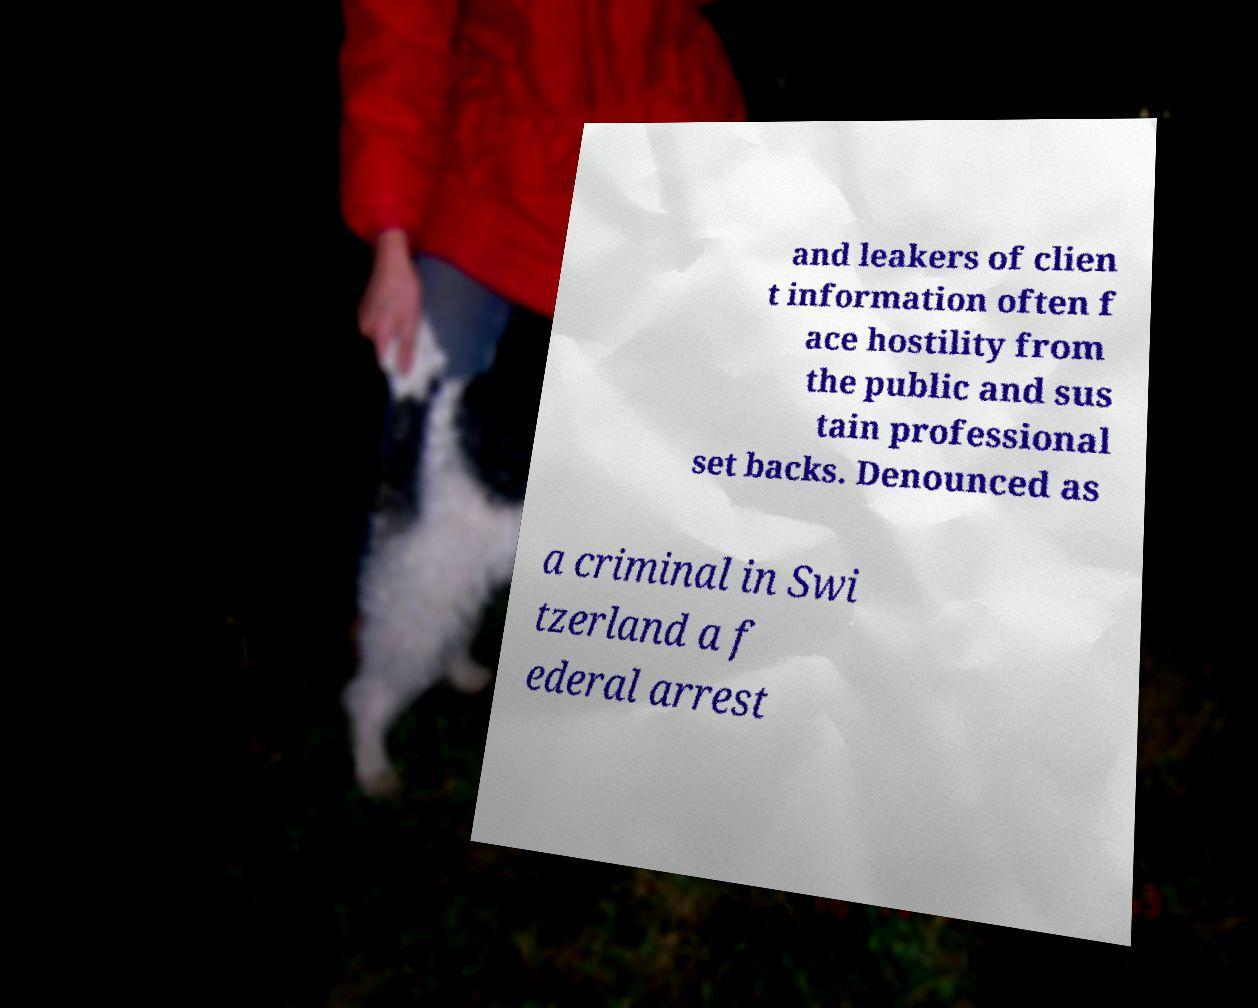What messages or text are displayed in this image? I need them in a readable, typed format. and leakers of clien t information often f ace hostility from the public and sus tain professional set backs. Denounced as a criminal in Swi tzerland a f ederal arrest 